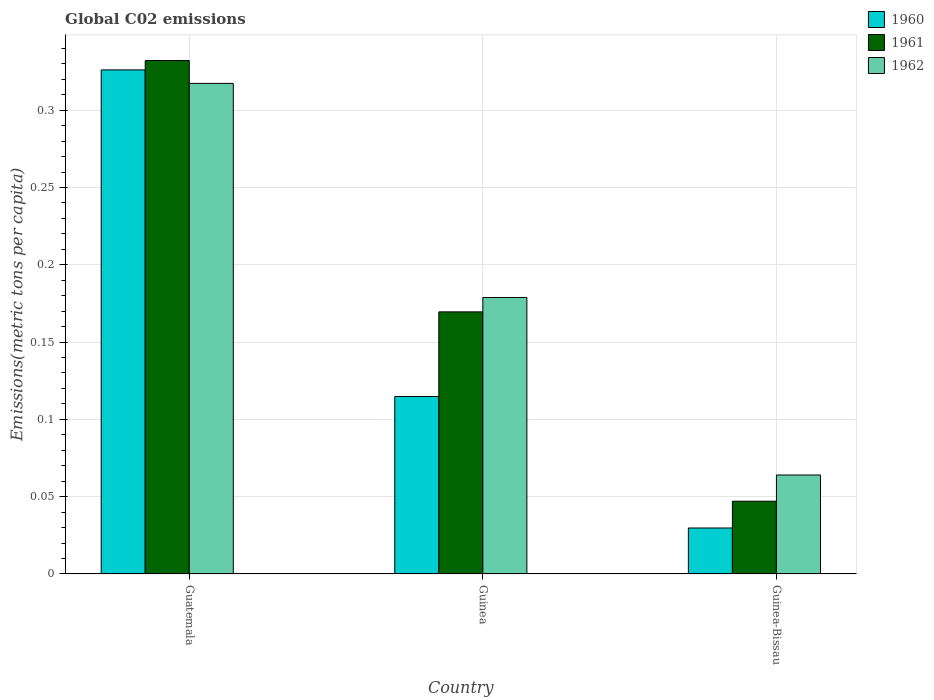Are the number of bars per tick equal to the number of legend labels?
Provide a succinct answer. Yes. How many bars are there on the 3rd tick from the right?
Your answer should be compact. 3. What is the label of the 2nd group of bars from the left?
Ensure brevity in your answer.  Guinea. What is the amount of CO2 emitted in in 1962 in Guinea?
Your answer should be very brief. 0.18. Across all countries, what is the maximum amount of CO2 emitted in in 1961?
Your response must be concise. 0.33. Across all countries, what is the minimum amount of CO2 emitted in in 1962?
Provide a short and direct response. 0.06. In which country was the amount of CO2 emitted in in 1961 maximum?
Make the answer very short. Guatemala. In which country was the amount of CO2 emitted in in 1960 minimum?
Make the answer very short. Guinea-Bissau. What is the total amount of CO2 emitted in in 1962 in the graph?
Offer a very short reply. 0.56. What is the difference between the amount of CO2 emitted in in 1960 in Guatemala and that in Guinea-Bissau?
Offer a terse response. 0.3. What is the difference between the amount of CO2 emitted in in 1960 in Guinea and the amount of CO2 emitted in in 1962 in Guatemala?
Give a very brief answer. -0.2. What is the average amount of CO2 emitted in in 1961 per country?
Your response must be concise. 0.18. What is the difference between the amount of CO2 emitted in of/in 1961 and amount of CO2 emitted in of/in 1960 in Guatemala?
Make the answer very short. 0.01. What is the ratio of the amount of CO2 emitted in in 1961 in Guinea to that in Guinea-Bissau?
Keep it short and to the point. 3.6. What is the difference between the highest and the second highest amount of CO2 emitted in in 1962?
Provide a short and direct response. 0.14. What is the difference between the highest and the lowest amount of CO2 emitted in in 1960?
Provide a short and direct response. 0.3. In how many countries, is the amount of CO2 emitted in in 1962 greater than the average amount of CO2 emitted in in 1962 taken over all countries?
Give a very brief answer. 1. What does the 3rd bar from the left in Guinea-Bissau represents?
Give a very brief answer. 1962. What does the 2nd bar from the right in Guatemala represents?
Ensure brevity in your answer.  1961. Is it the case that in every country, the sum of the amount of CO2 emitted in in 1961 and amount of CO2 emitted in in 1962 is greater than the amount of CO2 emitted in in 1960?
Make the answer very short. Yes. How many bars are there?
Ensure brevity in your answer.  9. Are all the bars in the graph horizontal?
Offer a very short reply. No. How many countries are there in the graph?
Give a very brief answer. 3. What is the difference between two consecutive major ticks on the Y-axis?
Offer a terse response. 0.05. Where does the legend appear in the graph?
Give a very brief answer. Top right. How are the legend labels stacked?
Offer a very short reply. Vertical. What is the title of the graph?
Your answer should be compact. Global C02 emissions. Does "1976" appear as one of the legend labels in the graph?
Provide a short and direct response. No. What is the label or title of the Y-axis?
Your answer should be very brief. Emissions(metric tons per capita). What is the Emissions(metric tons per capita) in 1960 in Guatemala?
Your answer should be very brief. 0.33. What is the Emissions(metric tons per capita) of 1961 in Guatemala?
Ensure brevity in your answer.  0.33. What is the Emissions(metric tons per capita) of 1962 in Guatemala?
Offer a very short reply. 0.32. What is the Emissions(metric tons per capita) in 1960 in Guinea?
Your answer should be compact. 0.11. What is the Emissions(metric tons per capita) of 1961 in Guinea?
Offer a terse response. 0.17. What is the Emissions(metric tons per capita) of 1962 in Guinea?
Make the answer very short. 0.18. What is the Emissions(metric tons per capita) in 1960 in Guinea-Bissau?
Provide a succinct answer. 0.03. What is the Emissions(metric tons per capita) of 1961 in Guinea-Bissau?
Provide a short and direct response. 0.05. What is the Emissions(metric tons per capita) of 1962 in Guinea-Bissau?
Offer a very short reply. 0.06. Across all countries, what is the maximum Emissions(metric tons per capita) in 1960?
Your answer should be very brief. 0.33. Across all countries, what is the maximum Emissions(metric tons per capita) of 1961?
Your answer should be compact. 0.33. Across all countries, what is the maximum Emissions(metric tons per capita) in 1962?
Your answer should be compact. 0.32. Across all countries, what is the minimum Emissions(metric tons per capita) in 1960?
Keep it short and to the point. 0.03. Across all countries, what is the minimum Emissions(metric tons per capita) of 1961?
Give a very brief answer. 0.05. Across all countries, what is the minimum Emissions(metric tons per capita) of 1962?
Provide a short and direct response. 0.06. What is the total Emissions(metric tons per capita) of 1960 in the graph?
Offer a very short reply. 0.47. What is the total Emissions(metric tons per capita) of 1961 in the graph?
Offer a very short reply. 0.55. What is the total Emissions(metric tons per capita) in 1962 in the graph?
Your answer should be compact. 0.56. What is the difference between the Emissions(metric tons per capita) in 1960 in Guatemala and that in Guinea?
Ensure brevity in your answer.  0.21. What is the difference between the Emissions(metric tons per capita) of 1961 in Guatemala and that in Guinea?
Keep it short and to the point. 0.16. What is the difference between the Emissions(metric tons per capita) of 1962 in Guatemala and that in Guinea?
Your answer should be very brief. 0.14. What is the difference between the Emissions(metric tons per capita) of 1960 in Guatemala and that in Guinea-Bissau?
Make the answer very short. 0.3. What is the difference between the Emissions(metric tons per capita) of 1961 in Guatemala and that in Guinea-Bissau?
Offer a very short reply. 0.28. What is the difference between the Emissions(metric tons per capita) of 1962 in Guatemala and that in Guinea-Bissau?
Give a very brief answer. 0.25. What is the difference between the Emissions(metric tons per capita) in 1960 in Guinea and that in Guinea-Bissau?
Provide a succinct answer. 0.09. What is the difference between the Emissions(metric tons per capita) of 1961 in Guinea and that in Guinea-Bissau?
Keep it short and to the point. 0.12. What is the difference between the Emissions(metric tons per capita) in 1962 in Guinea and that in Guinea-Bissau?
Provide a short and direct response. 0.11. What is the difference between the Emissions(metric tons per capita) in 1960 in Guatemala and the Emissions(metric tons per capita) in 1961 in Guinea?
Keep it short and to the point. 0.16. What is the difference between the Emissions(metric tons per capita) in 1960 in Guatemala and the Emissions(metric tons per capita) in 1962 in Guinea?
Your answer should be very brief. 0.15. What is the difference between the Emissions(metric tons per capita) of 1961 in Guatemala and the Emissions(metric tons per capita) of 1962 in Guinea?
Your answer should be compact. 0.15. What is the difference between the Emissions(metric tons per capita) of 1960 in Guatemala and the Emissions(metric tons per capita) of 1961 in Guinea-Bissau?
Provide a short and direct response. 0.28. What is the difference between the Emissions(metric tons per capita) in 1960 in Guatemala and the Emissions(metric tons per capita) in 1962 in Guinea-Bissau?
Your response must be concise. 0.26. What is the difference between the Emissions(metric tons per capita) of 1961 in Guatemala and the Emissions(metric tons per capita) of 1962 in Guinea-Bissau?
Your answer should be very brief. 0.27. What is the difference between the Emissions(metric tons per capita) of 1960 in Guinea and the Emissions(metric tons per capita) of 1961 in Guinea-Bissau?
Ensure brevity in your answer.  0.07. What is the difference between the Emissions(metric tons per capita) in 1960 in Guinea and the Emissions(metric tons per capita) in 1962 in Guinea-Bissau?
Offer a very short reply. 0.05. What is the difference between the Emissions(metric tons per capita) in 1961 in Guinea and the Emissions(metric tons per capita) in 1962 in Guinea-Bissau?
Keep it short and to the point. 0.11. What is the average Emissions(metric tons per capita) in 1960 per country?
Your answer should be very brief. 0.16. What is the average Emissions(metric tons per capita) of 1961 per country?
Keep it short and to the point. 0.18. What is the average Emissions(metric tons per capita) in 1962 per country?
Your answer should be compact. 0.19. What is the difference between the Emissions(metric tons per capita) in 1960 and Emissions(metric tons per capita) in 1961 in Guatemala?
Ensure brevity in your answer.  -0.01. What is the difference between the Emissions(metric tons per capita) in 1960 and Emissions(metric tons per capita) in 1962 in Guatemala?
Provide a short and direct response. 0.01. What is the difference between the Emissions(metric tons per capita) in 1961 and Emissions(metric tons per capita) in 1962 in Guatemala?
Your response must be concise. 0.01. What is the difference between the Emissions(metric tons per capita) in 1960 and Emissions(metric tons per capita) in 1961 in Guinea?
Provide a short and direct response. -0.05. What is the difference between the Emissions(metric tons per capita) in 1960 and Emissions(metric tons per capita) in 1962 in Guinea?
Offer a very short reply. -0.06. What is the difference between the Emissions(metric tons per capita) in 1961 and Emissions(metric tons per capita) in 1962 in Guinea?
Make the answer very short. -0.01. What is the difference between the Emissions(metric tons per capita) of 1960 and Emissions(metric tons per capita) of 1961 in Guinea-Bissau?
Offer a very short reply. -0.02. What is the difference between the Emissions(metric tons per capita) of 1960 and Emissions(metric tons per capita) of 1962 in Guinea-Bissau?
Provide a succinct answer. -0.03. What is the difference between the Emissions(metric tons per capita) of 1961 and Emissions(metric tons per capita) of 1962 in Guinea-Bissau?
Your response must be concise. -0.02. What is the ratio of the Emissions(metric tons per capita) of 1960 in Guatemala to that in Guinea?
Provide a succinct answer. 2.84. What is the ratio of the Emissions(metric tons per capita) in 1961 in Guatemala to that in Guinea?
Provide a succinct answer. 1.96. What is the ratio of the Emissions(metric tons per capita) of 1962 in Guatemala to that in Guinea?
Provide a succinct answer. 1.77. What is the ratio of the Emissions(metric tons per capita) in 1960 in Guatemala to that in Guinea-Bissau?
Keep it short and to the point. 10.96. What is the ratio of the Emissions(metric tons per capita) of 1961 in Guatemala to that in Guinea-Bissau?
Offer a very short reply. 7.06. What is the ratio of the Emissions(metric tons per capita) of 1962 in Guatemala to that in Guinea-Bissau?
Give a very brief answer. 4.96. What is the ratio of the Emissions(metric tons per capita) of 1960 in Guinea to that in Guinea-Bissau?
Offer a terse response. 3.86. What is the ratio of the Emissions(metric tons per capita) of 1961 in Guinea to that in Guinea-Bissau?
Make the answer very short. 3.6. What is the ratio of the Emissions(metric tons per capita) of 1962 in Guinea to that in Guinea-Bissau?
Make the answer very short. 2.79. What is the difference between the highest and the second highest Emissions(metric tons per capita) of 1960?
Keep it short and to the point. 0.21. What is the difference between the highest and the second highest Emissions(metric tons per capita) of 1961?
Give a very brief answer. 0.16. What is the difference between the highest and the second highest Emissions(metric tons per capita) in 1962?
Your response must be concise. 0.14. What is the difference between the highest and the lowest Emissions(metric tons per capita) in 1960?
Make the answer very short. 0.3. What is the difference between the highest and the lowest Emissions(metric tons per capita) of 1961?
Your answer should be compact. 0.28. What is the difference between the highest and the lowest Emissions(metric tons per capita) of 1962?
Offer a very short reply. 0.25. 